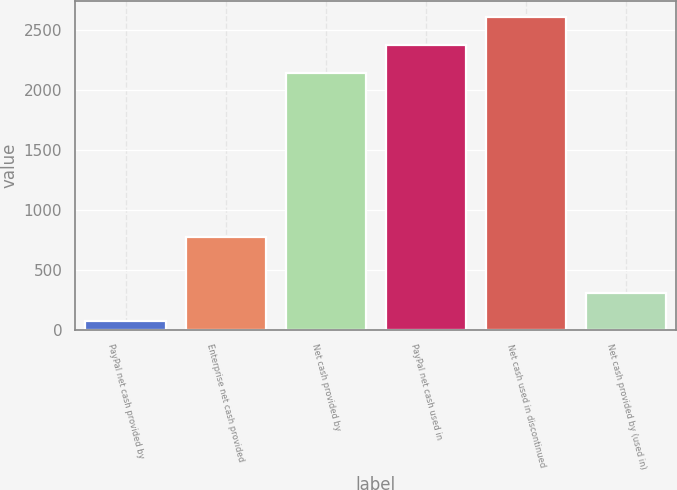Convert chart to OTSL. <chart><loc_0><loc_0><loc_500><loc_500><bar_chart><fcel>PayPal net cash provided by<fcel>Enterprise net cash provided<fcel>Net cash provided by<fcel>PayPal net cash used in<fcel>Net cash used in discontinued<fcel>Net cash provided by (used in)<nl><fcel>76<fcel>770.8<fcel>2144.6<fcel>2376.2<fcel>2607.8<fcel>307.6<nl></chart> 